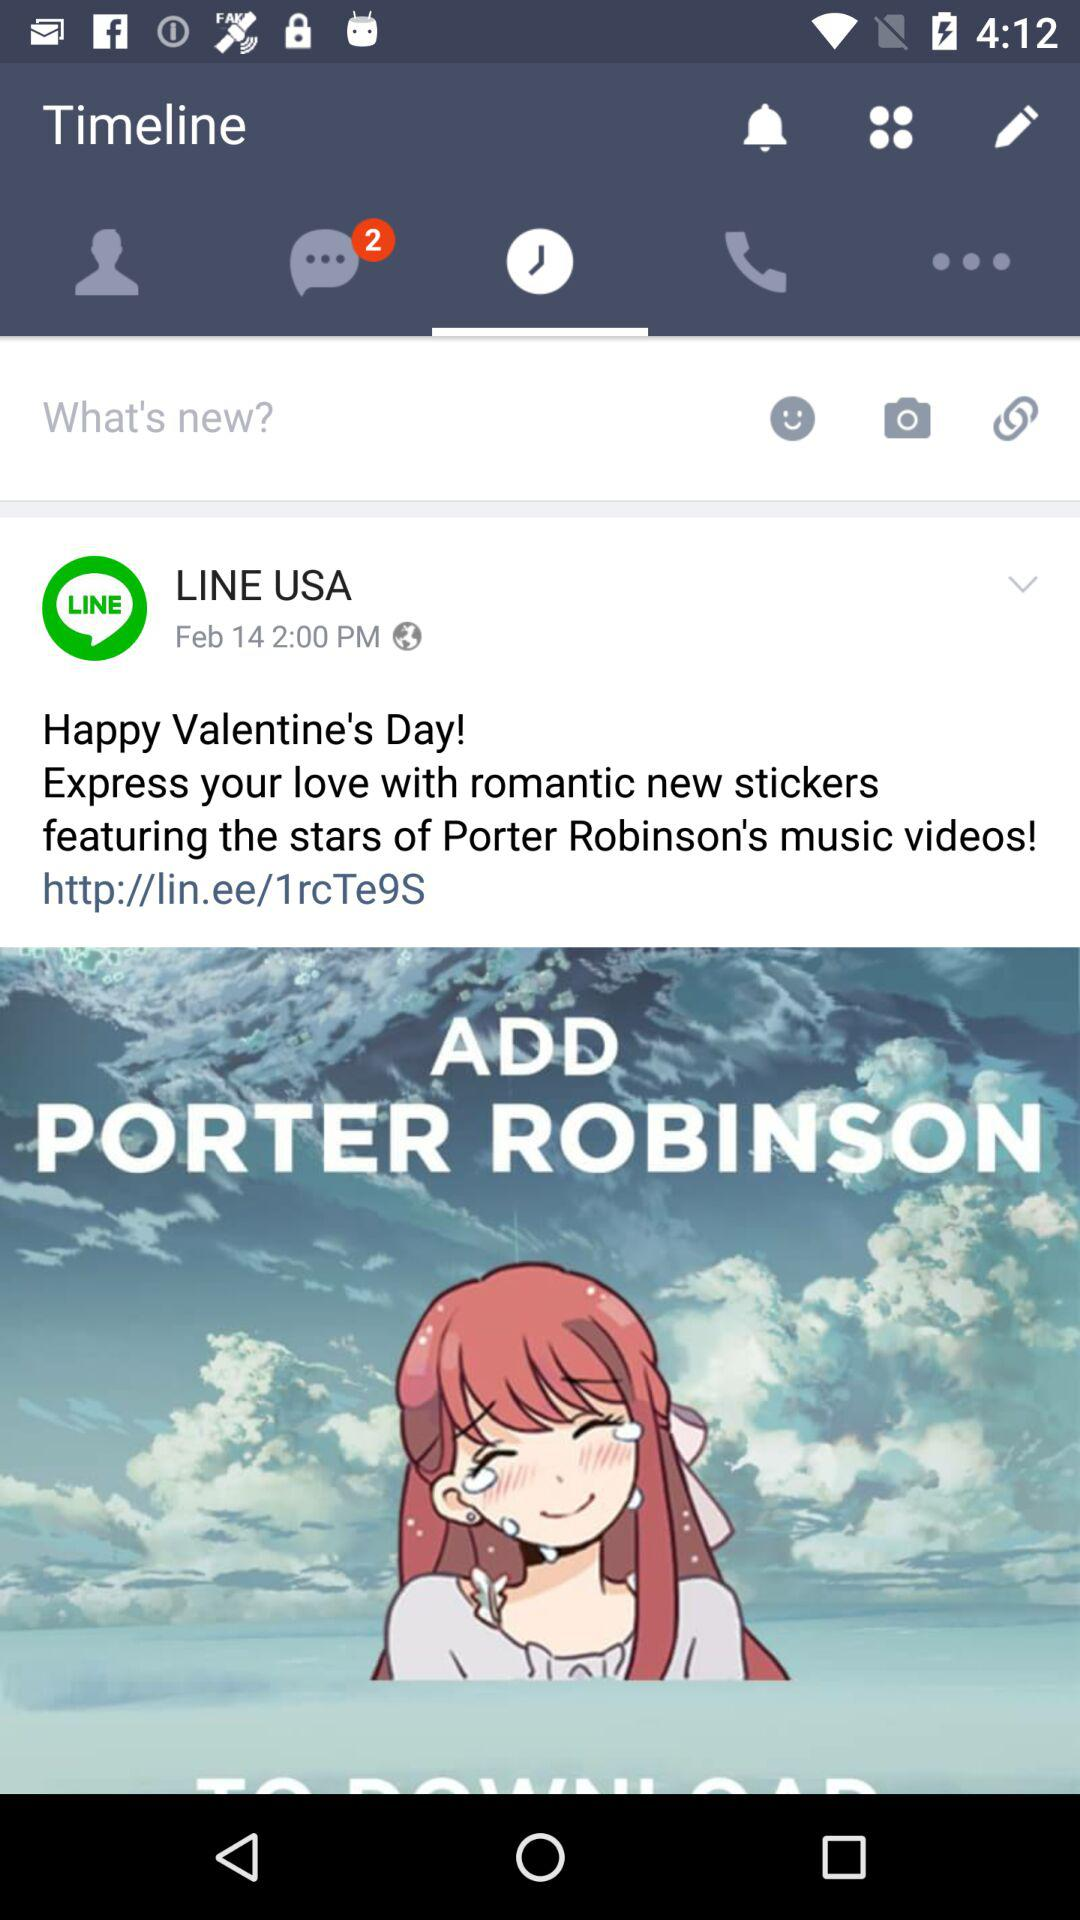What's the number of notifications on chat?
Answer the question using a single word or phrase. The number of notifications on chat is 2.2 